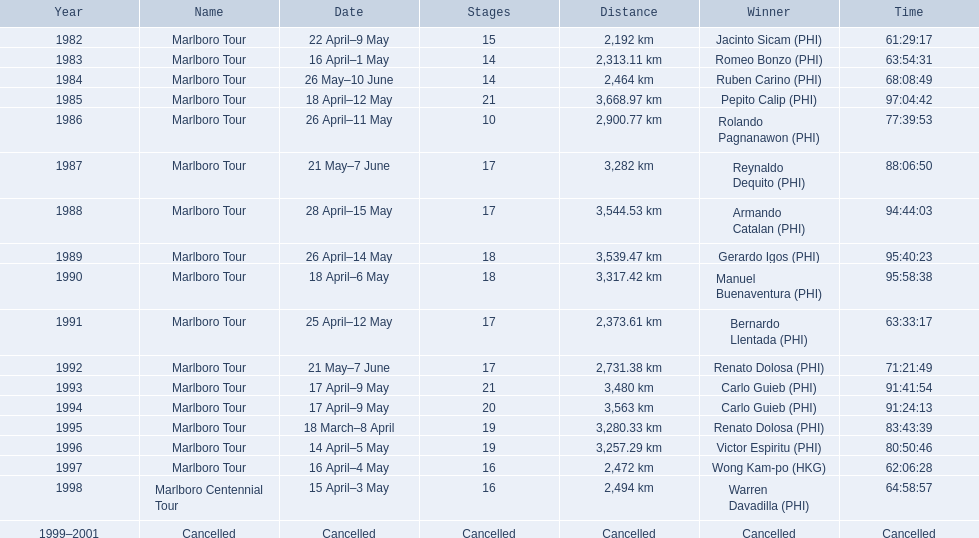Who were all of the winners? Jacinto Sicam (PHI), Romeo Bonzo (PHI), Ruben Carino (PHI), Pepito Calip (PHI), Rolando Pagnanawon (PHI), Reynaldo Dequito (PHI), Armando Catalan (PHI), Gerardo Igos (PHI), Manuel Buenaventura (PHI), Bernardo Llentada (PHI), Renato Dolosa (PHI), Carlo Guieb (PHI), Carlo Guieb (PHI), Renato Dolosa (PHI), Victor Espiritu (PHI), Wong Kam-po (HKG), Warren Davadilla (PHI), Cancelled. When did they compete? 1982, 1983, 1984, 1985, 1986, 1987, 1988, 1989, 1990, 1991, 1992, 1993, 1994, 1995, 1996, 1997, 1998, 1999–2001. What were their finishing times? 61:29:17, 63:54:31, 68:08:49, 97:04:42, 77:39:53, 88:06:50, 94:44:03, 95:40:23, 95:58:38, 63:33:17, 71:21:49, 91:41:54, 91:24:13, 83:43:39, 80:50:46, 62:06:28, 64:58:57, Cancelled. Can you give me this table as a dict? {'header': ['Year', 'Name', 'Date', 'Stages', 'Distance', 'Winner', 'Time'], 'rows': [['1982', 'Marlboro Tour', '22 April–9 May', '15', '2,192\xa0km', 'Jacinto Sicam\xa0(PHI)', '61:29:17'], ['1983', 'Marlboro Tour', '16 April–1 May', '14', '2,313.11\xa0km', 'Romeo Bonzo\xa0(PHI)', '63:54:31'], ['1984', 'Marlboro Tour', '26 May–10 June', '14', '2,464\xa0km', 'Ruben Carino\xa0(PHI)', '68:08:49'], ['1985', 'Marlboro Tour', '18 April–12 May', '21', '3,668.97\xa0km', 'Pepito Calip\xa0(PHI)', '97:04:42'], ['1986', 'Marlboro Tour', '26 April–11 May', '10', '2,900.77\xa0km', 'Rolando Pagnanawon\xa0(PHI)', '77:39:53'], ['1987', 'Marlboro Tour', '21 May–7 June', '17', '3,282\xa0km', 'Reynaldo Dequito\xa0(PHI)', '88:06:50'], ['1988', 'Marlboro Tour', '28 April–15 May', '17', '3,544.53\xa0km', 'Armando Catalan\xa0(PHI)', '94:44:03'], ['1989', 'Marlboro Tour', '26 April–14 May', '18', '3,539.47\xa0km', 'Gerardo Igos\xa0(PHI)', '95:40:23'], ['1990', 'Marlboro Tour', '18 April–6 May', '18', '3,317.42\xa0km', 'Manuel Buenaventura\xa0(PHI)', '95:58:38'], ['1991', 'Marlboro Tour', '25 April–12 May', '17', '2,373.61\xa0km', 'Bernardo Llentada\xa0(PHI)', '63:33:17'], ['1992', 'Marlboro Tour', '21 May–7 June', '17', '2,731.38\xa0km', 'Renato Dolosa\xa0(PHI)', '71:21:49'], ['1993', 'Marlboro Tour', '17 April–9 May', '21', '3,480\xa0km', 'Carlo Guieb\xa0(PHI)', '91:41:54'], ['1994', 'Marlboro Tour', '17 April–9 May', '20', '3,563\xa0km', 'Carlo Guieb\xa0(PHI)', '91:24:13'], ['1995', 'Marlboro Tour', '18 March–8 April', '19', '3,280.33\xa0km', 'Renato Dolosa\xa0(PHI)', '83:43:39'], ['1996', 'Marlboro Tour', '14 April–5 May', '19', '3,257.29\xa0km', 'Victor Espiritu\xa0(PHI)', '80:50:46'], ['1997', 'Marlboro Tour', '16 April–4 May', '16', '2,472\xa0km', 'Wong Kam-po\xa0(HKG)', '62:06:28'], ['1998', 'Marlboro Centennial Tour', '15 April–3 May', '16', '2,494\xa0km', 'Warren Davadilla\xa0(PHI)', '64:58:57'], ['1999–2001', 'Cancelled', 'Cancelled', 'Cancelled', 'Cancelled', 'Cancelled', 'Cancelled']]} And who won during 1998? Warren Davadilla (PHI). What was his time? 64:58:57. 